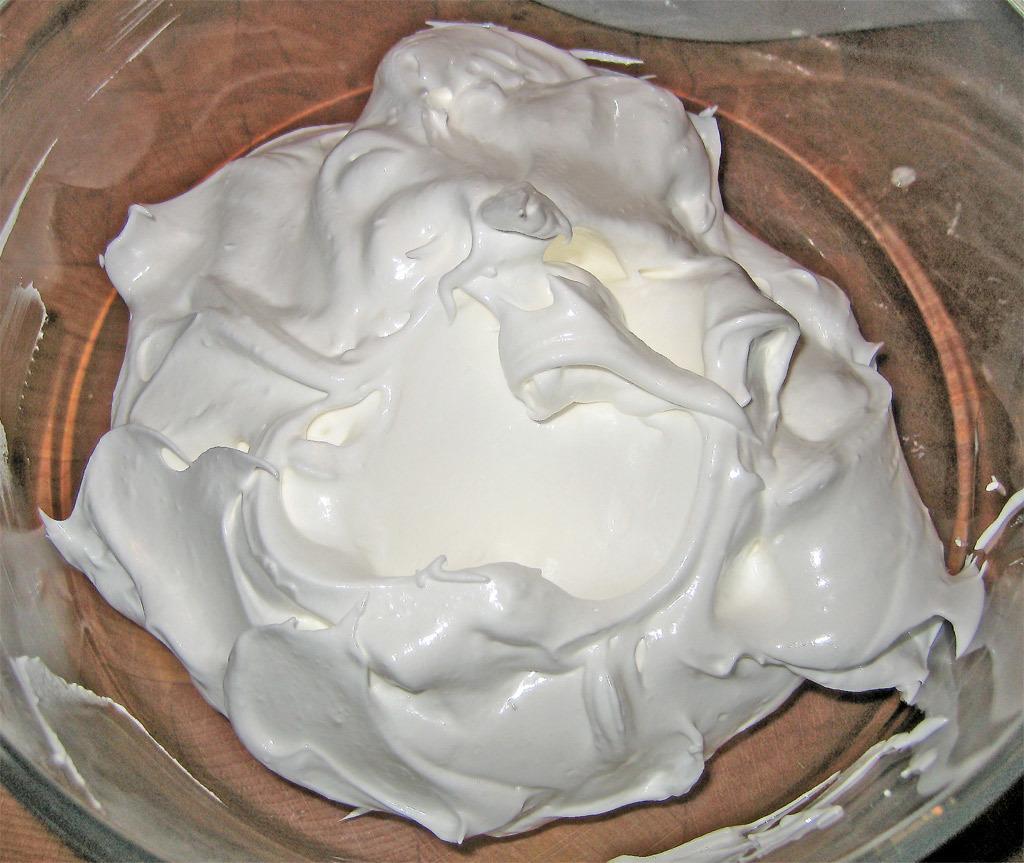Describe this image in one or two sentences. In the image we can see there is a cream kept in the glass. 